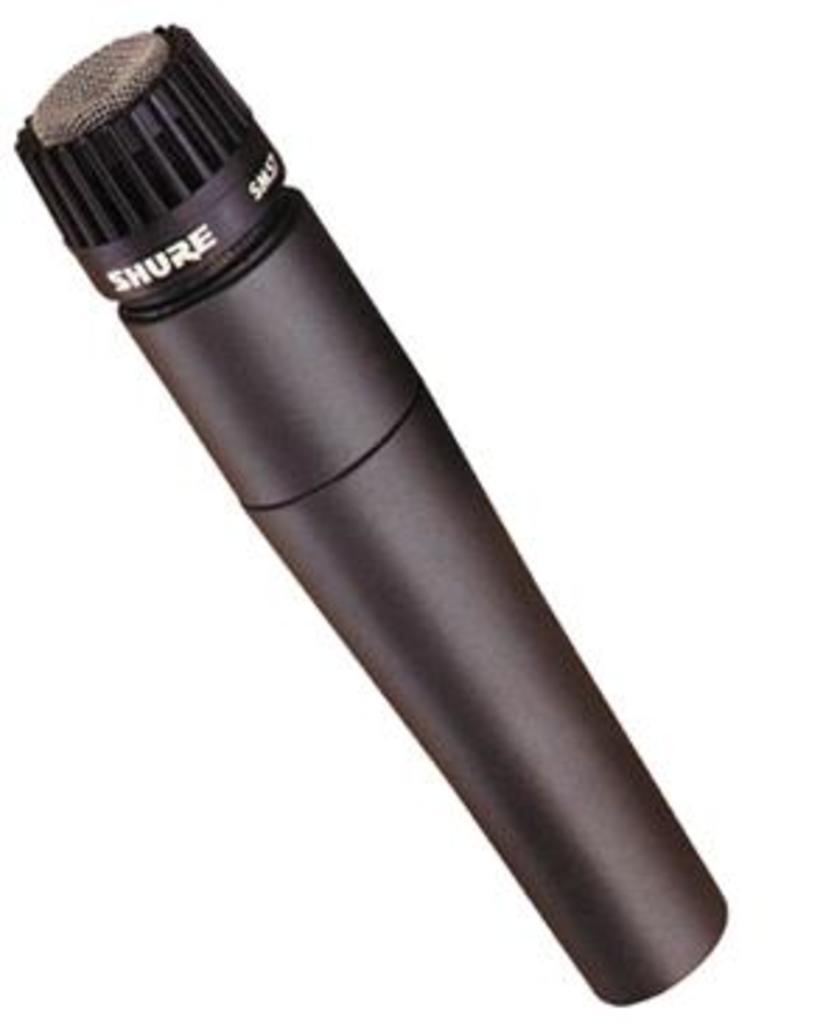What is the main object in the image? There is a mic in the image. What is the amount of gold present in the image? There is no gold present in the image; it only features a mic. What shape is the mic in the image? The shape of the mic cannot be determined from the image alone, as it is a two-dimensional representation. 